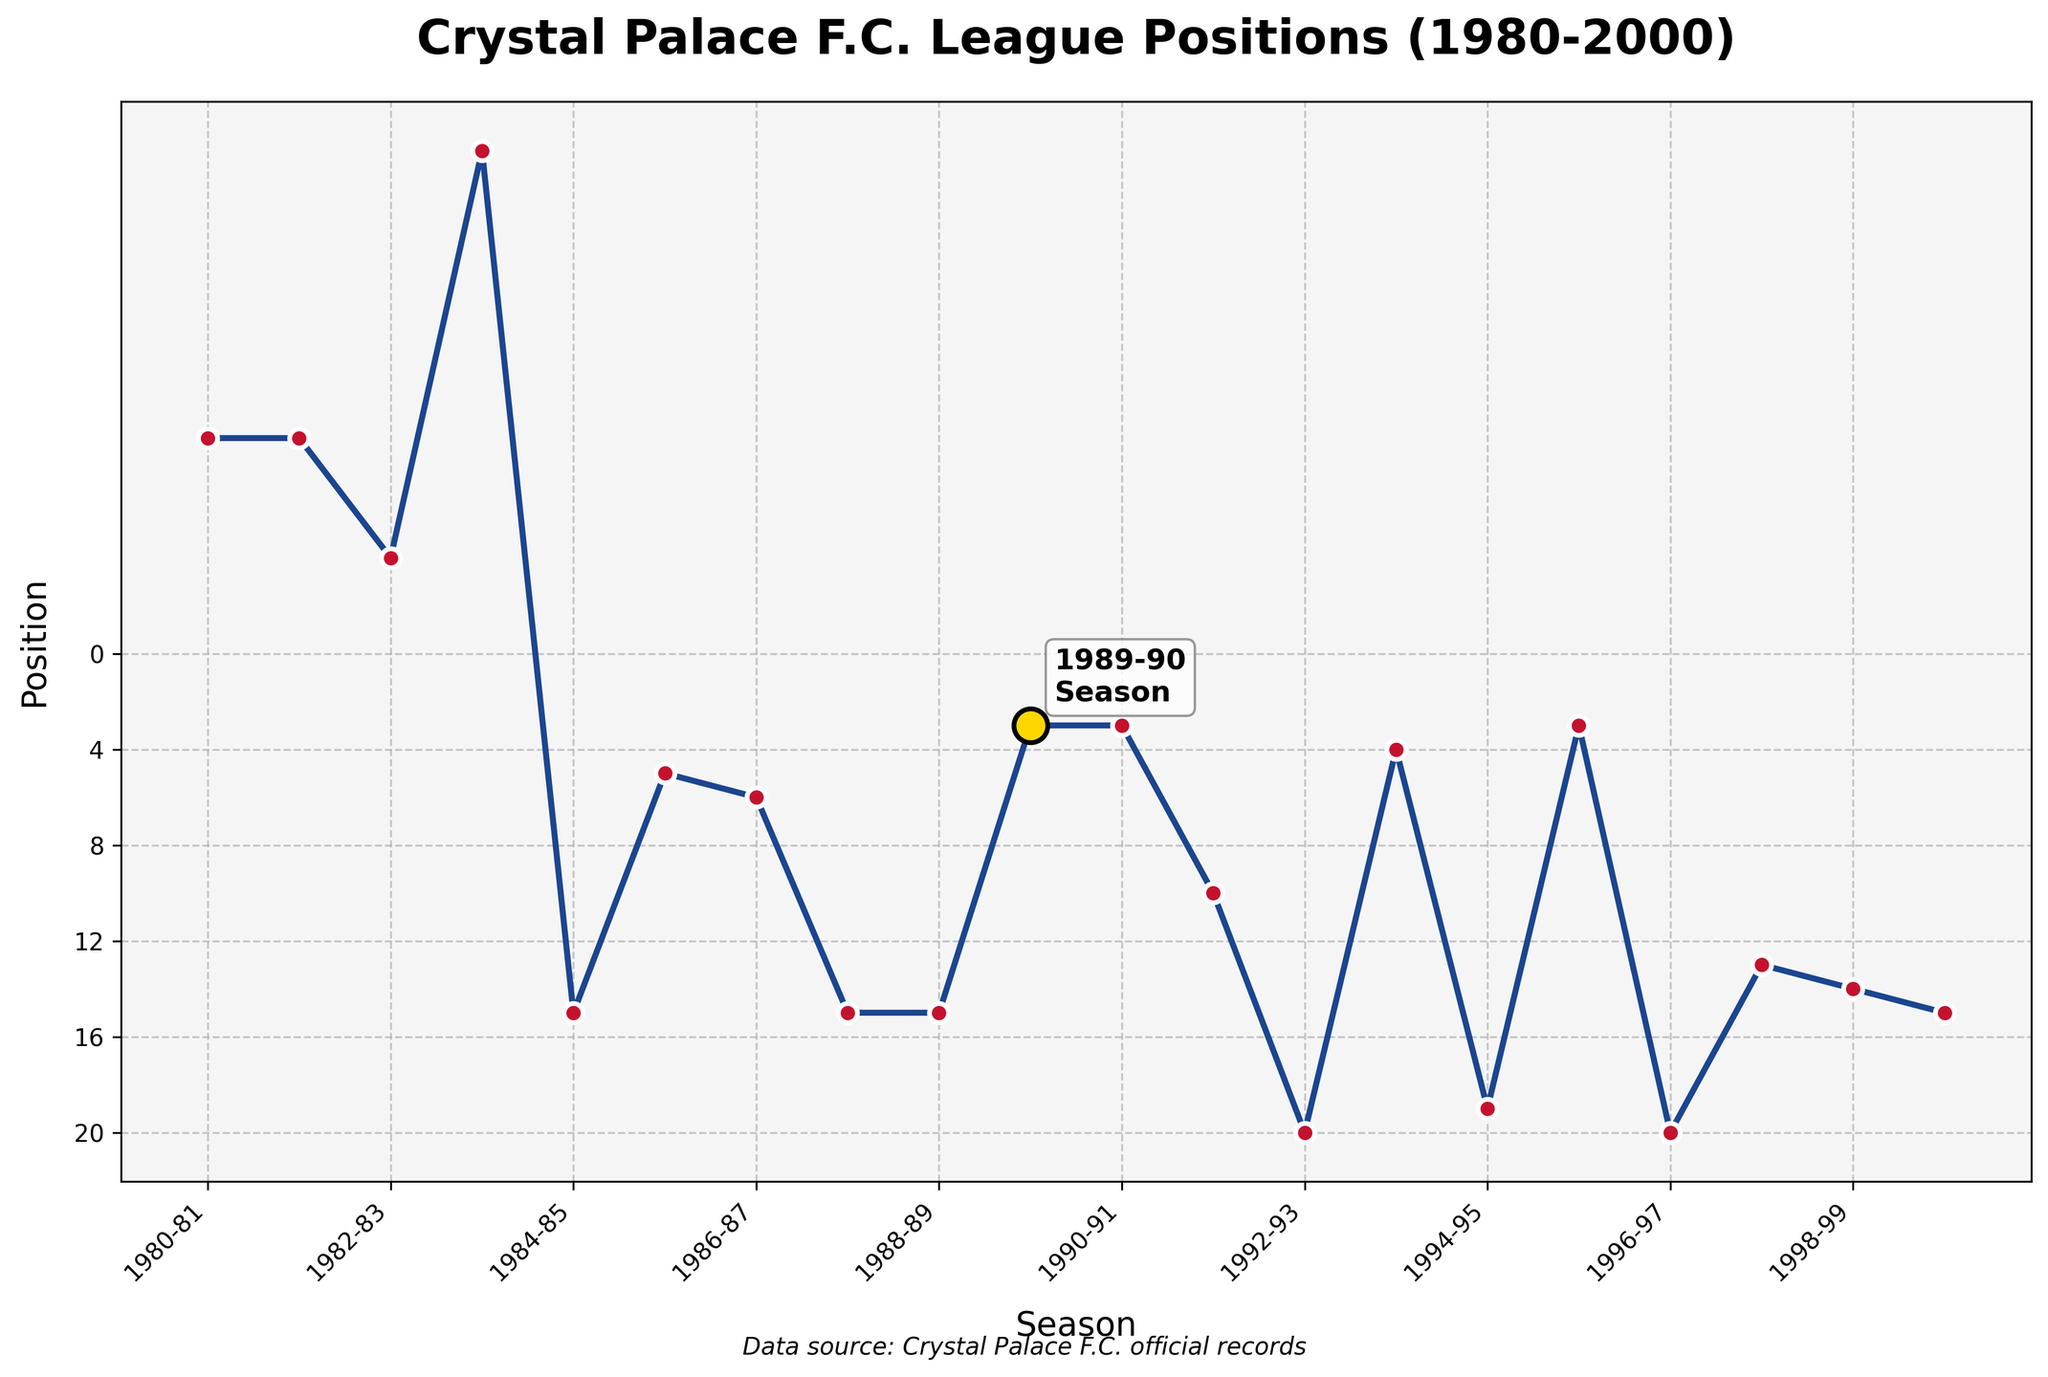How did Crystal Palace's league position change between the 1989-90 and 1992-93 seasons? To determine the change, look at the adjusted positions for the 1989-90 and 1992-93 seasons. In 1989-90, they were 3rd in the First Division (3), and in 1992-93, they were 20th in the Premier League (20). The change is 20 - 3 = 17 positions.
Answer: 17 positions Which season saw Crystal Palace achieve its highest league position in the given time period? The highest league position is the lowest numerical value in the adjusted positions. The best was 3rd in the 1989-90 and 1990-91 seasons.
Answer: 1989-90 and 1990-91 How many times did Crystal Palace finish in the top 5 of their league from 1980 to 2000? Identify seasons where the adjusted position is 5 or lower. They finished in the top 5 in 1983-84 (3rd), 1985-86 (5th), 1986-87 (6th), 1989-90 (3rd), 1990-91 (3rd). Count these occurrences.
Answer: 3 times What was Crystal Palace's league position trend from 1986-87 to 1989-90? Review the adjusted positions for these seasons: 1986-87 (6), 1987-88 (15), 1988-89 (15), and 1989-90 (3). The pattern shows some fluctuation and then a significant improvement in 1989-90.
Answer: Fluctuated and improved significantly In which league did Crystal Palace spend most of their time according to the chart? Count the seasons spent in each league: First Division (16 seasons), Premier League (3 seasons), Second Division (3 seasons).
Answer: First Division What significant change happened between the 1990-91 and 1992-93 seasons? Review the adjusted positions: 1990-91 (3), 1991-92 (10), and 1992-93 (20). There was a drop from 3rd to 10th, followed by relegation to 20th.
Answer: Significant drop and relegation How many times was Crystal Palace promoted or relegated during this period? Identify changes in leagues between consecutive seasons. Promotions: 1983-84 to 1984-85, 1993-94 to 1994-95, 1995-96 to 1996-97. Relegations: 1992-93 to 1993-94, 1994-95 to 1995-96, 1996-97 to 1997-98. Count these changes.
Answer: 6 times What visual element highlights the 1989-90 season in the chart? Look for visual cues such as colors and symbols. The 1989-90 season is highlighted with a gold marker and a label annotation.
Answer: Gold marker and label Compare Crystal Palace's performance in the 1983-84 and 1995-96 seasons. Check the adjusted positions for both seasons: 1983-84 (3 in Second Division) and 1995-96 (3 in First Division). Both seasons ended with similar positions, indicating promotion years.
Answer: Both achieved 3rd place and promotion What pattern can be observed in Crystal Palace's league positions from the start to the end of the 1990s? Review league positions from 1990-91 to 1999-00. Initially high (3rd), then fluctuating mid-low (20th, 4th, 19th, 3rd, 20th, 13th, and finally 15th).
Answer: High to fluctuating mid-low positions 